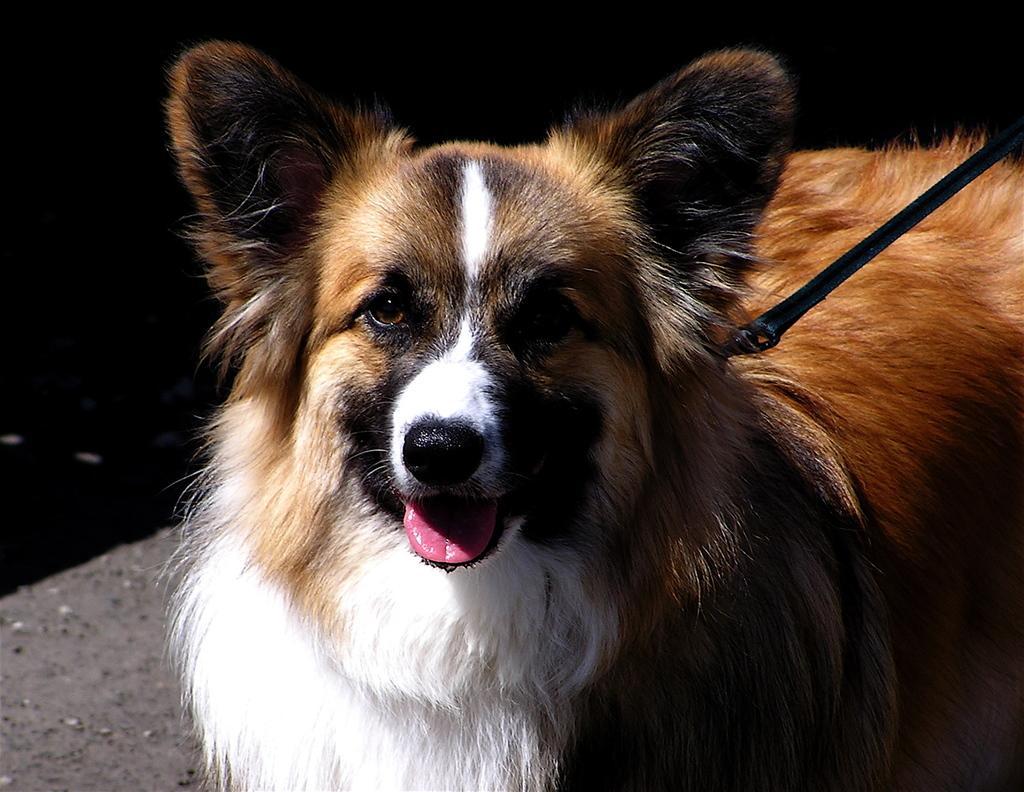In one or two sentences, can you explain what this image depicts? In this picture, we see a dog which is in brown and white color. The dog is looking at the camera. We even see a black color belt around its neck. In the background, it is black color. 